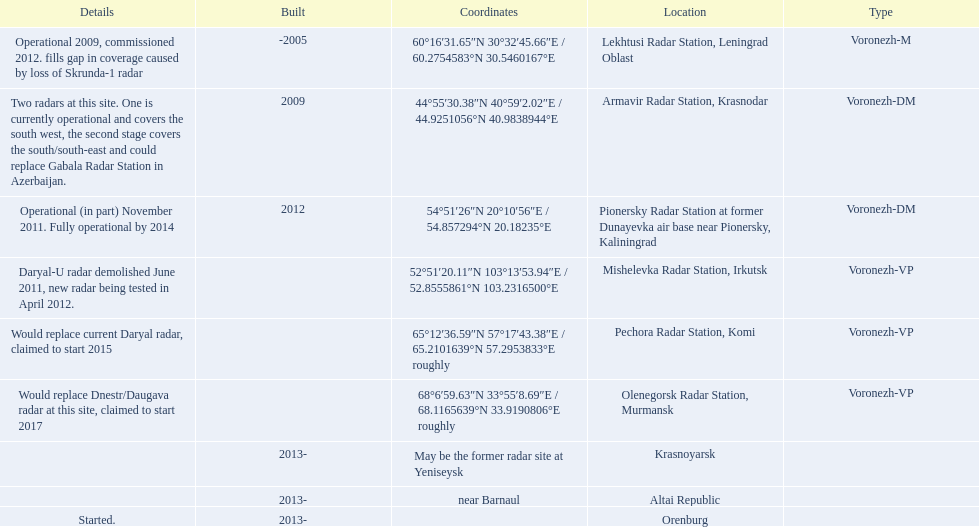What year built is at the top? -2005. 